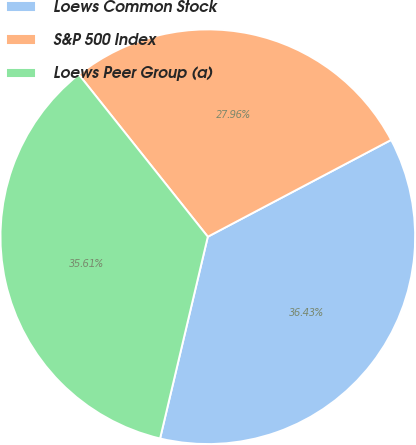Convert chart. <chart><loc_0><loc_0><loc_500><loc_500><pie_chart><fcel>Loews Common Stock<fcel>S&P 500 Index<fcel>Loews Peer Group (a)<nl><fcel>36.43%<fcel>27.96%<fcel>35.61%<nl></chart> 